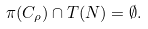Convert formula to latex. <formula><loc_0><loc_0><loc_500><loc_500>\pi ( C _ { \rho } ) \cap T ( N ) = \emptyset .</formula> 